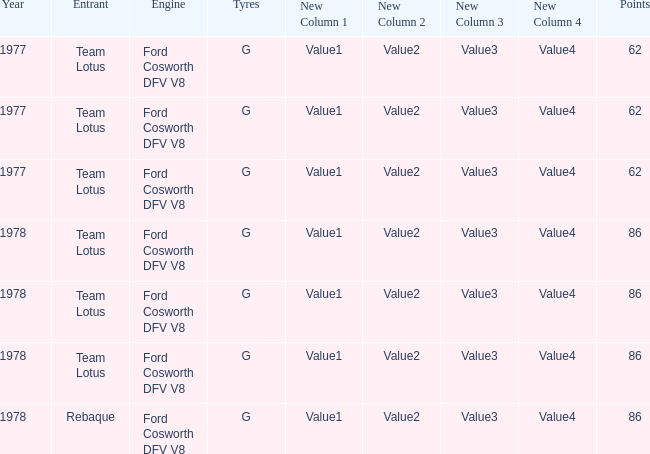What is the Focus that has a Year bigger than 1977? 86, 86, 86, 86. 